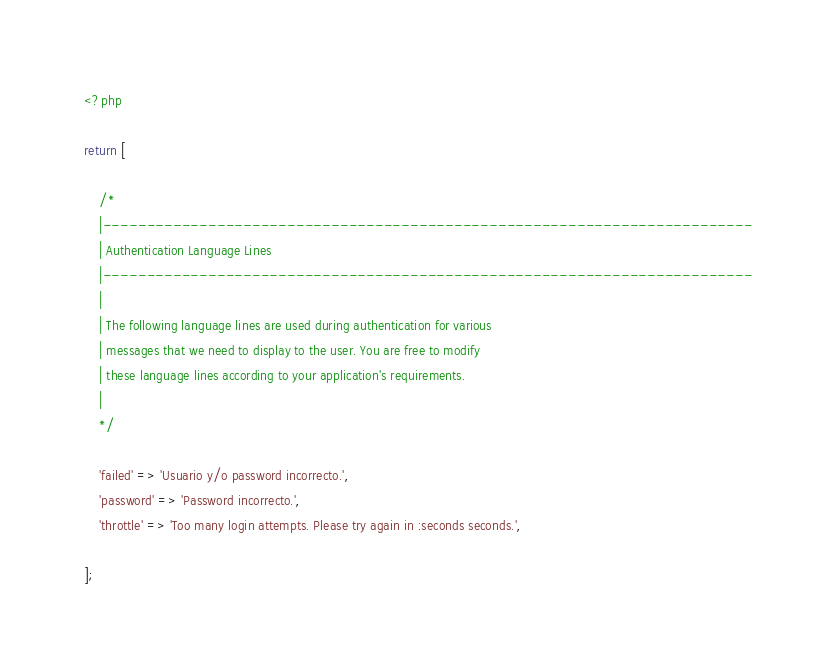<code> <loc_0><loc_0><loc_500><loc_500><_PHP_><?php

return [

    /*
    |--------------------------------------------------------------------------
    | Authentication Language Lines
    |--------------------------------------------------------------------------
    |
    | The following language lines are used during authentication for various
    | messages that we need to display to the user. You are free to modify
    | these language lines according to your application's requirements.
    |
    */

    'failed' => 'Usuario y/o password incorrecto.',
    'password' => 'Password incorrecto.',
    'throttle' => 'Too many login attempts. Please try again in :seconds seconds.',

];
</code> 